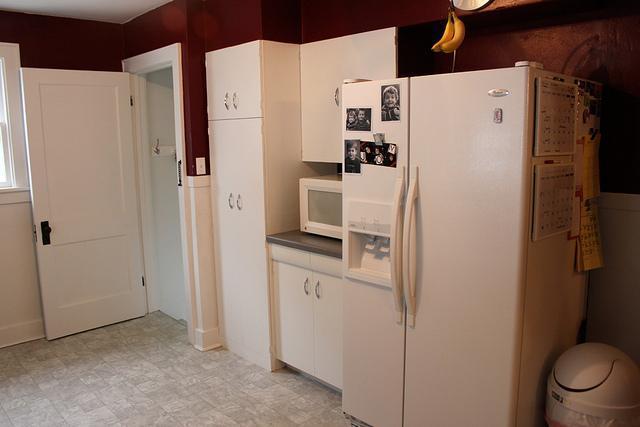What is on the side of the refrigerator?
Select the accurate answer and provide justification: `Answer: choice
Rationale: srationale.`
Options: Dog, laundry basket, cat, garbage disposal. Answer: garbage disposal.
Rationale: There is a bin next to the fridge that is used for disposal of garbage. What is the state of the bananas?
Indicate the correct response by choosing from the four available options to answer the question.
Options: Overripe, ripe, underripe, rotten. Ripe. 